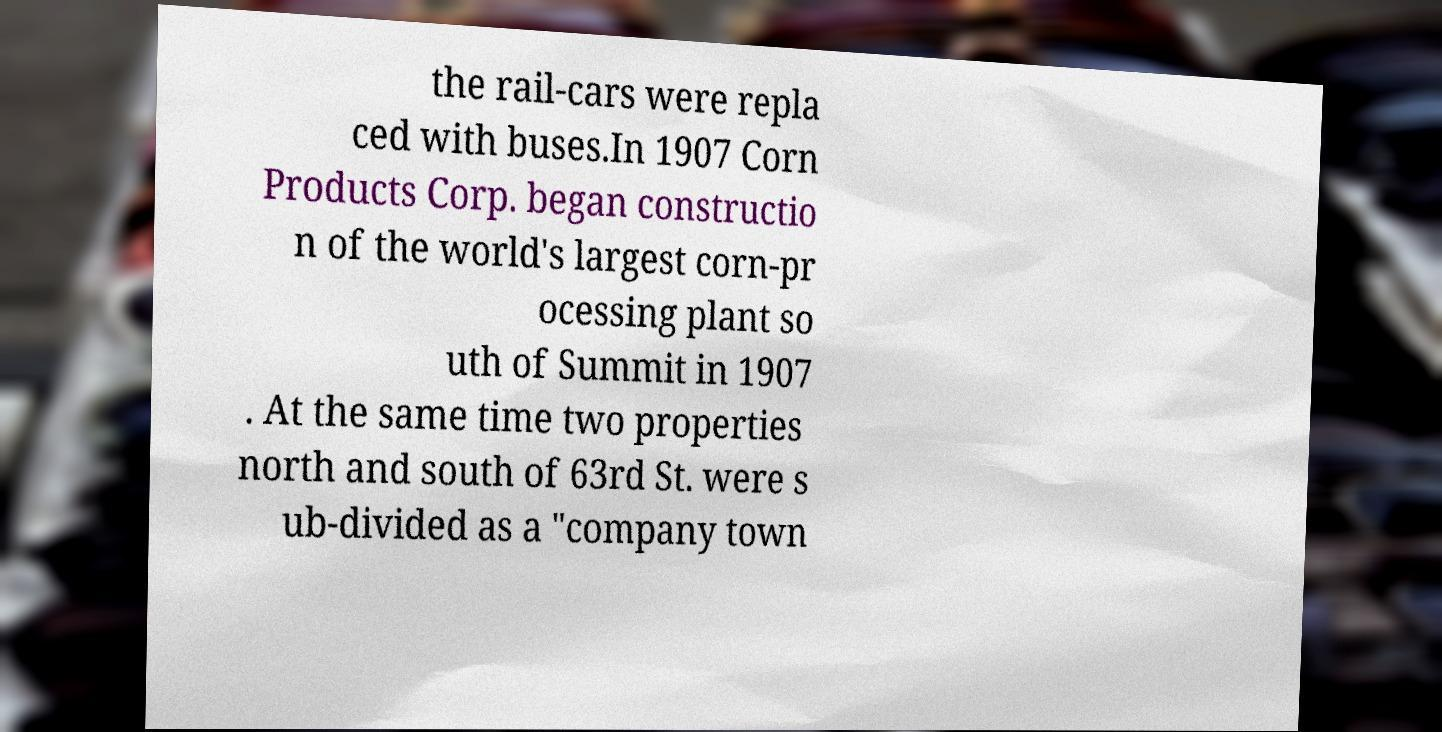For documentation purposes, I need the text within this image transcribed. Could you provide that? the rail-cars were repla ced with buses.In 1907 Corn Products Corp. began constructio n of the world's largest corn-pr ocessing plant so uth of Summit in 1907 . At the same time two properties north and south of 63rd St. were s ub-divided as a "company town 